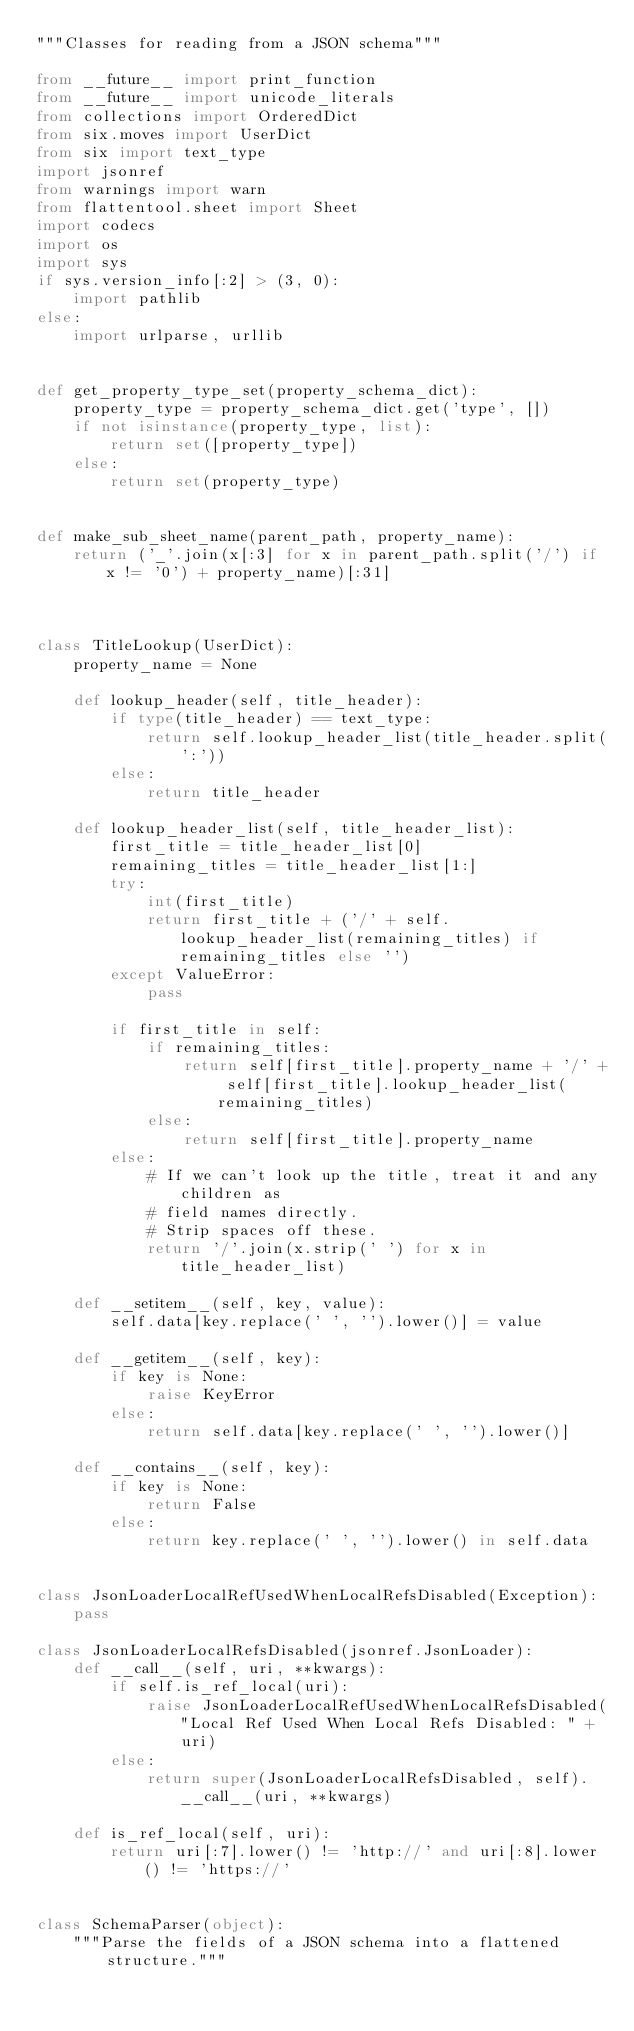Convert code to text. <code><loc_0><loc_0><loc_500><loc_500><_Python_>"""Classes for reading from a JSON schema"""

from __future__ import print_function
from __future__ import unicode_literals
from collections import OrderedDict
from six.moves import UserDict
from six import text_type
import jsonref
from warnings import warn
from flattentool.sheet import Sheet
import codecs
import os
import sys
if sys.version_info[:2] > (3, 0):
    import pathlib
else:
    import urlparse, urllib


def get_property_type_set(property_schema_dict):
    property_type = property_schema_dict.get('type', [])
    if not isinstance(property_type, list):
        return set([property_type])
    else:
        return set(property_type)


def make_sub_sheet_name(parent_path, property_name):
    return ('_'.join(x[:3] for x in parent_path.split('/') if x != '0') + property_name)[:31]



class TitleLookup(UserDict):
    property_name = None

    def lookup_header(self, title_header):
        if type(title_header) == text_type:
            return self.lookup_header_list(title_header.split(':'))
        else:
            return title_header

    def lookup_header_list(self, title_header_list):
        first_title = title_header_list[0]
        remaining_titles = title_header_list[1:]
        try:
            int(first_title)
            return first_title + ('/' + self.lookup_header_list(remaining_titles) if remaining_titles else '')
        except ValueError:
            pass

        if first_title in self:
            if remaining_titles:
                return self[first_title].property_name + '/' + self[first_title].lookup_header_list(remaining_titles)
            else:
                return self[first_title].property_name
        else:
            # If we can't look up the title, treat it and any children as
            # field names directly.
            # Strip spaces off these.
            return '/'.join(x.strip(' ') for x in title_header_list)

    def __setitem__(self, key, value):
        self.data[key.replace(' ', '').lower()] = value

    def __getitem__(self, key):
        if key is None:
            raise KeyError
        else:
            return self.data[key.replace(' ', '').lower()]

    def __contains__(self, key):
        if key is None:
            return False
        else:
            return key.replace(' ', '').lower() in self.data


class JsonLoaderLocalRefUsedWhenLocalRefsDisabled(Exception):
    pass

class JsonLoaderLocalRefsDisabled(jsonref.JsonLoader):
    def __call__(self, uri, **kwargs):
        if self.is_ref_local(uri):
            raise JsonLoaderLocalRefUsedWhenLocalRefsDisabled("Local Ref Used When Local Refs Disabled: " + uri)
        else:
            return super(JsonLoaderLocalRefsDisabled, self).__call__(uri, **kwargs)

    def is_ref_local(self, uri):
        return uri[:7].lower() != 'http://' and uri[:8].lower() != 'https://'


class SchemaParser(object):
    """Parse the fields of a JSON schema into a flattened structure."""
</code> 